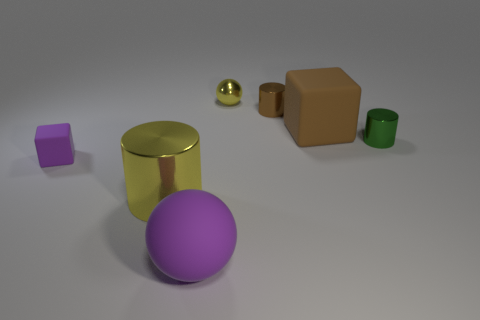Add 1 yellow shiny spheres. How many objects exist? 8 Subtract all cubes. How many objects are left? 5 Add 2 big metallic objects. How many big metallic objects exist? 3 Subtract 1 brown cylinders. How many objects are left? 6 Subtract all small blue matte objects. Subtract all large shiny objects. How many objects are left? 6 Add 2 yellow cylinders. How many yellow cylinders are left? 3 